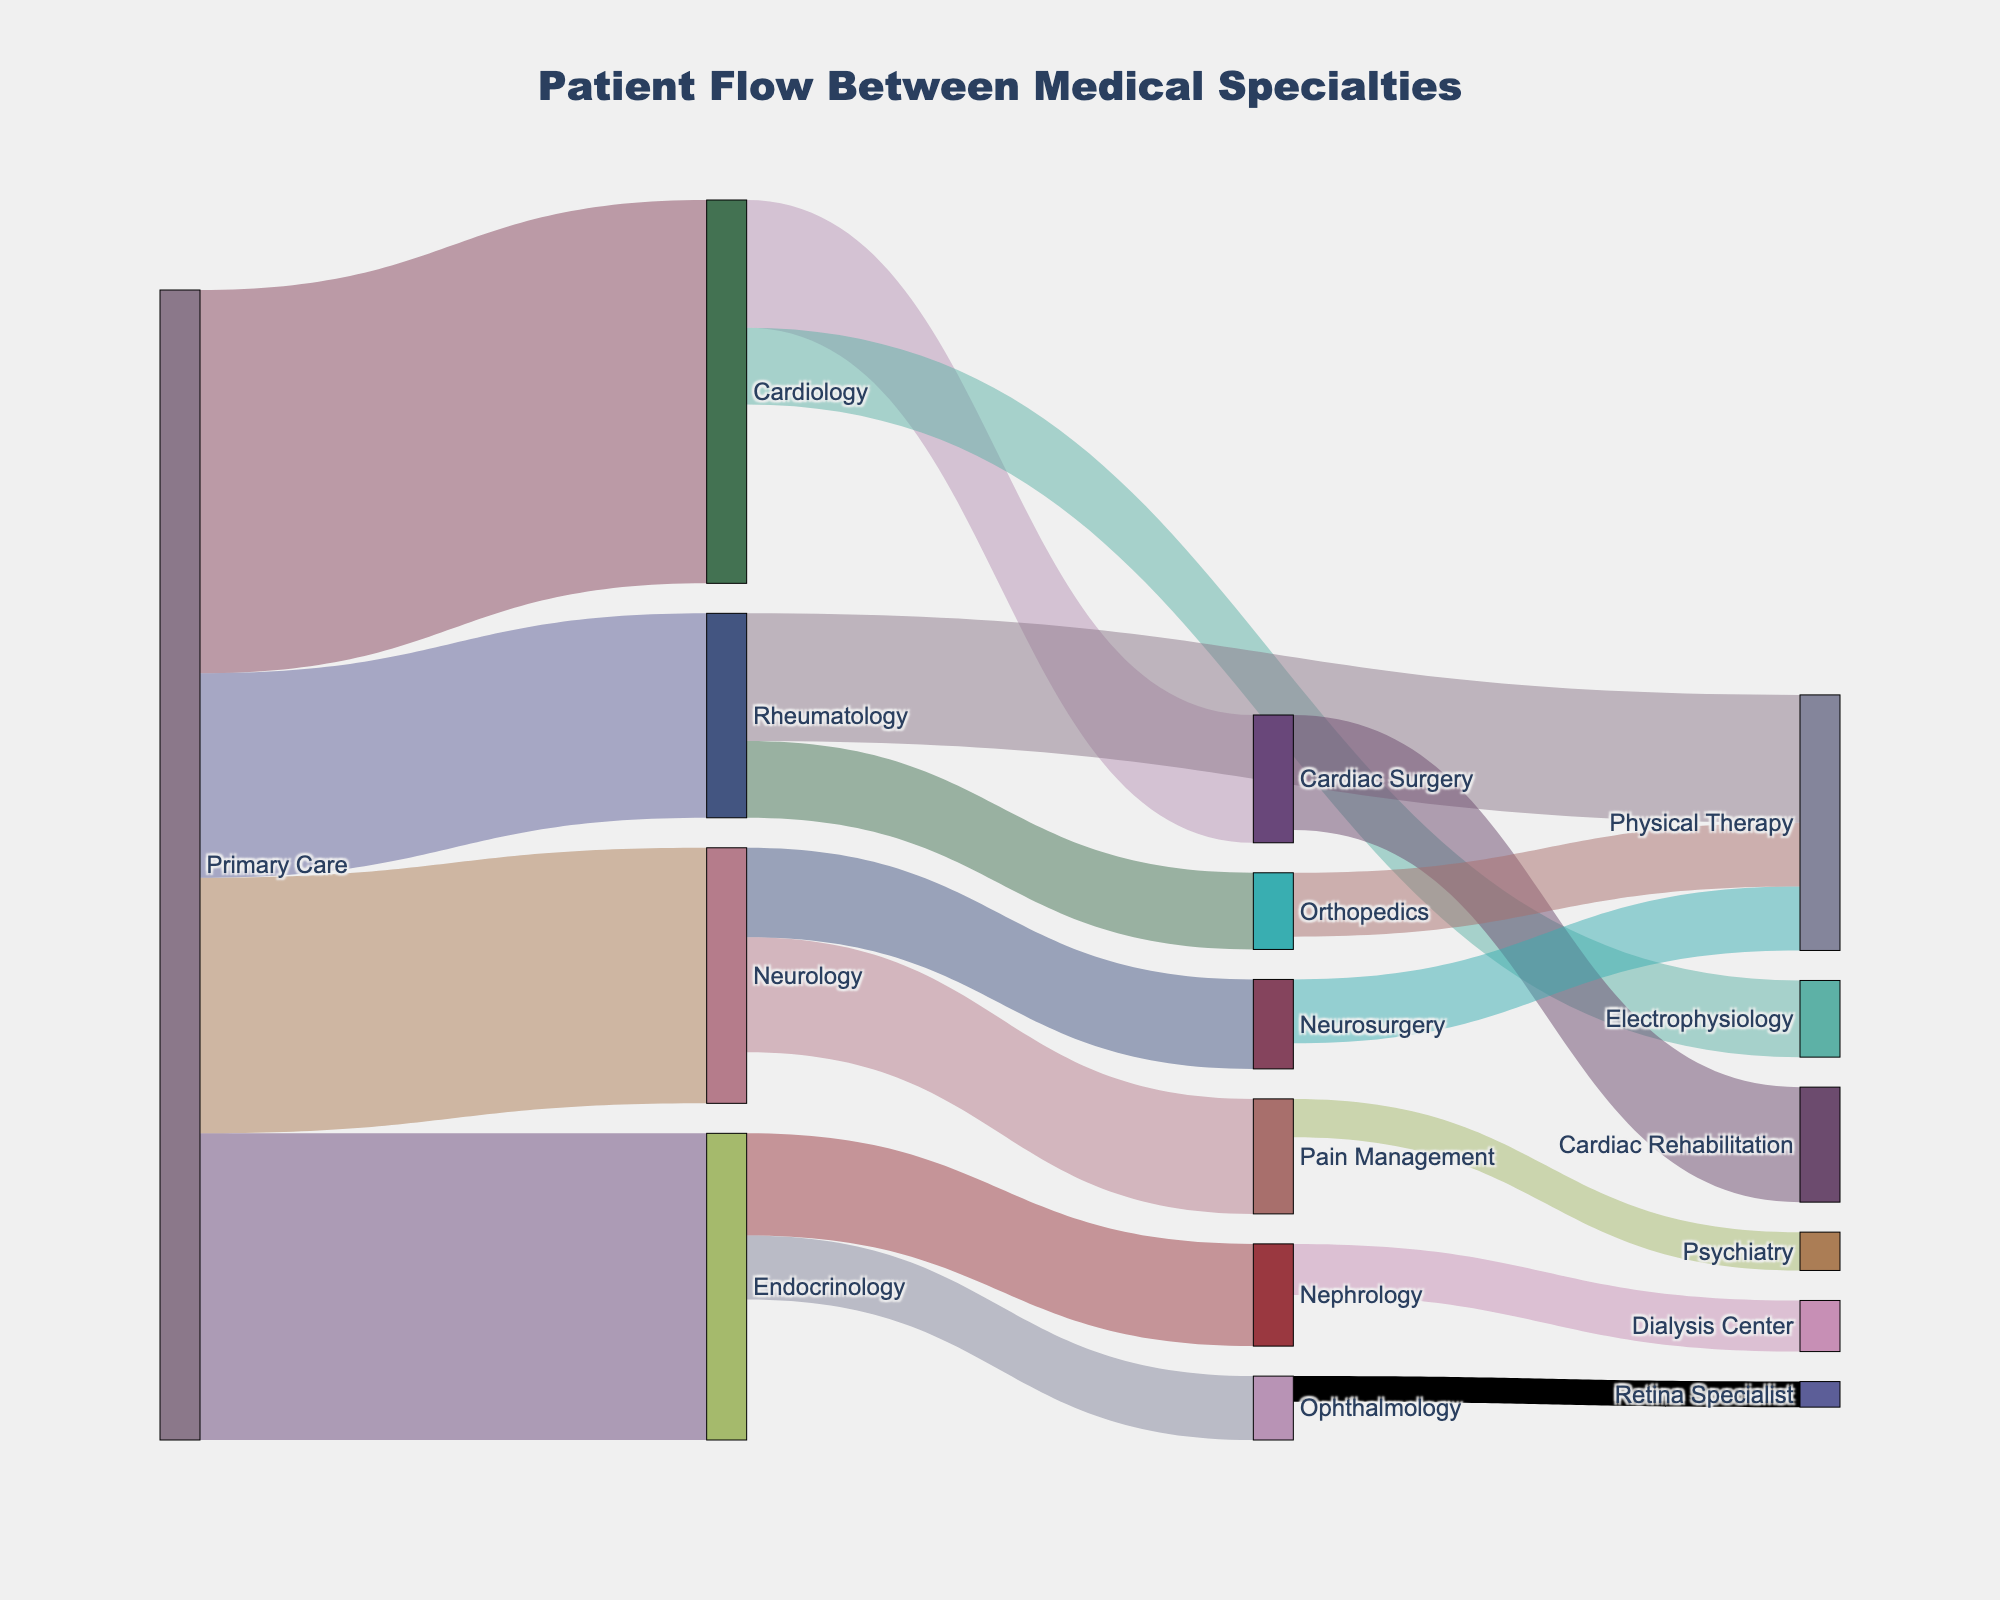What is the title of the Sankey diagram? The title of the Sankey diagram is typically displayed prominently at the top of the figure. It provides context for what the visualization is depicting. In this case, the title is "Patient Flow Between Medical Specialties".
Answer: Patient Flow Between Medical Specialties How many patients flowed from Primary Care to Cardiology? This can be determined by locating the link from Primary Care to Cardiology on the Sankey diagram and reading the associated value. According to the data provided, 150 patients flowed from Primary Care to Cardiology.
Answer: 150 Which specialty received the most patients from Primary Care? To determine this, look at all the flows originating from Primary Care and compare their values. The specialty that received the most patients is the one with the highest value. Endocrinology received 120, Neurology 100, Rheumatology 80, and Cardiology 150. Cardiology received the most patients.
Answer: Cardiology What is the sum of patients that flowed from Primary Care to all other specialties? Sum up all the values for patients flowing from Primary Care: Cardiology (150), Endocrinology (120), Neurology (100), and Rheumatology (80). The total is 150 + 120 + 100 + 80 = 450.
Answer: 450 Which specialty has both incoming and outgoing flows? By inspecting the diagram, we can see which specialties have arrows pointing to and from them. Cardiology has flows incoming from Primary Care and outgoing to Cardiac Surgery and Electrophysiology. Other specialties with both incoming and outgoing flows include Endocrinology, Neurology, and Rheumatology.
Answer: Cardiology, Endocrinology, Neurology, Rheumatology How many patients were referred from Endocrinology to Nephrology? Locate the link from Endocrinology to Nephrology and check its value. According to the provided data, 40 patients were referred from Endocrinology to Nephrology.
Answer: 40 Which specialty received patients from both Cardiology and Rheumatology? By examining the links starting from Cardiology and Rheumatology, we find that Physical Therapy receives patients from both specialties: Rheumatology to Physical Therapy (50) and Cardiology to Cardiac Surgery, which ultimately connects to Cardiac Rehabilitation.
Answer: None (direct connection), Complex mapping needed What is the difference in the number of patients flowing from Primary Care to Cardiology versus from Primary Care to Rheumatology? Calculate the difference between the patient flows from Primary Care to these two specialties: Cardiology (150) and Rheumatology (80). The difference is 150 - 80 = 70.
Answer: 70 Which specialty has the smallest value for incoming patients from another specialty? Check the values for all incoming patient flows across the specialties and identify the smallest one. According to the data, Ophthalmology has 25, Physical Therapy 25, Psychiatry 15, etc. The smallest value is for the Retina Specialist with 10 incoming patients from Ophthalmology.
Answer: Retina Specialist What is the average number of patients flowing into each specialty from all the given sources? To determine the average, sum all the values for patient flows into each specialty and divide by the number of specialties receiving patients. The sum of all values is 150 + 120 + 100 + 80 + 50 + 30 + 40 + 25 + 35 + 45 + 30 + 50 + 45 + 20 + 25 + 15 + 25 + 10 = 895, divided by 18 specialties gives an average of 895/18.
Answer: 49.72 